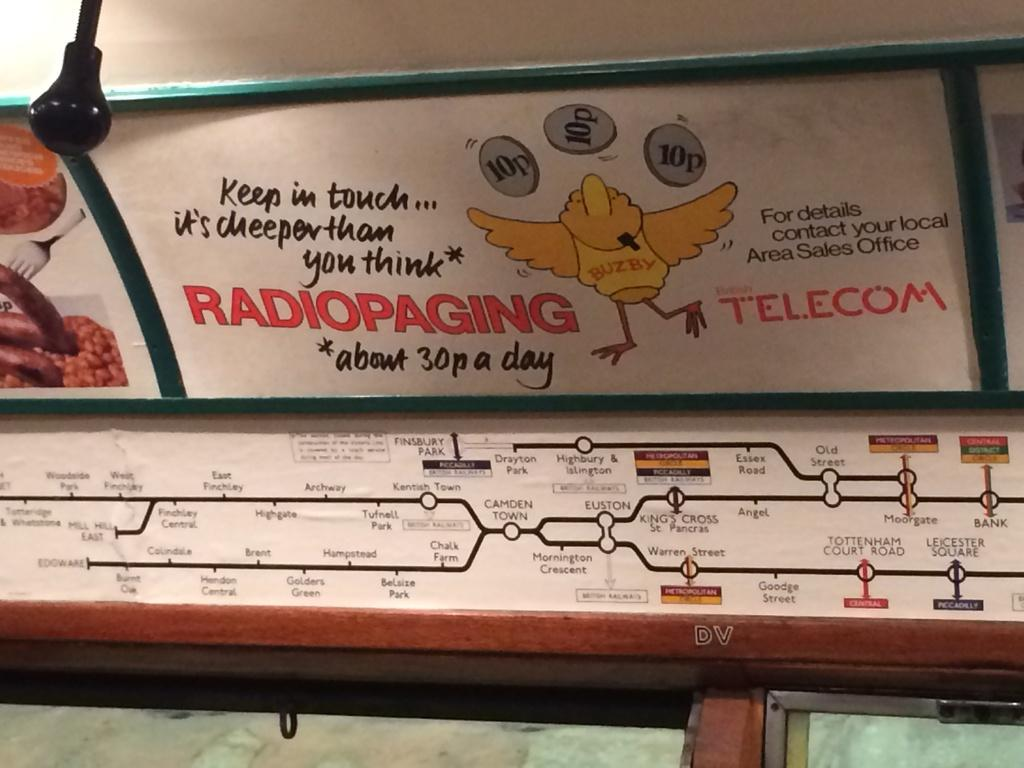<image>
Create a compact narrative representing the image presented. A map of different transport stations including Kings Cross. 